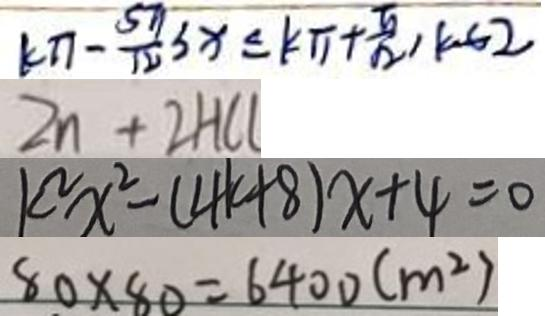<formula> <loc_0><loc_0><loc_500><loc_500>( k \pi - \frac { 5 \pi } { 1 2 } ) 3 x \leq k \pi + \frac { \pi } { 1 2 } , k \in 2 
 Z n + 2 H C l 
 k ^ { 2 } x ^ { 2 } - ( 4 k + 8 ) x + 4 = 0 
 8 0 \times 8 0 = 6 4 0 0 ( m ^ { 2 } )</formula> 